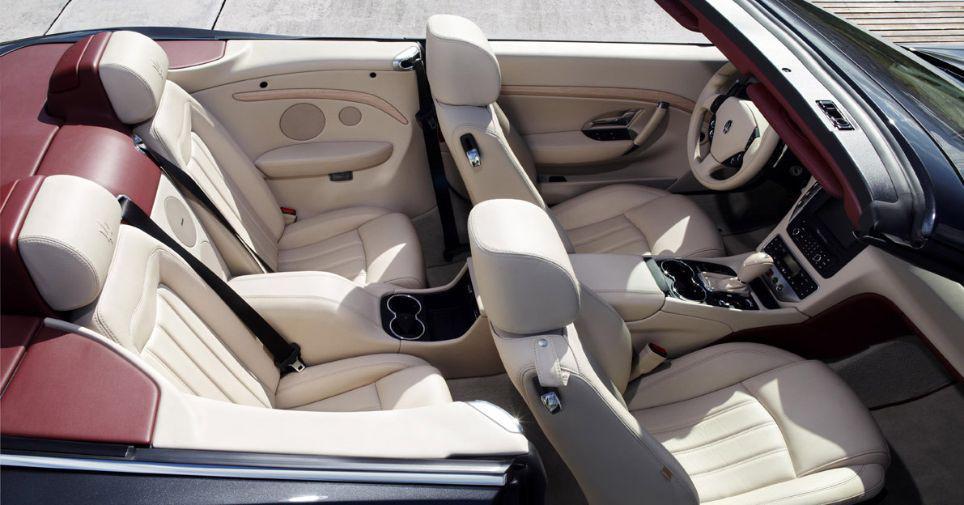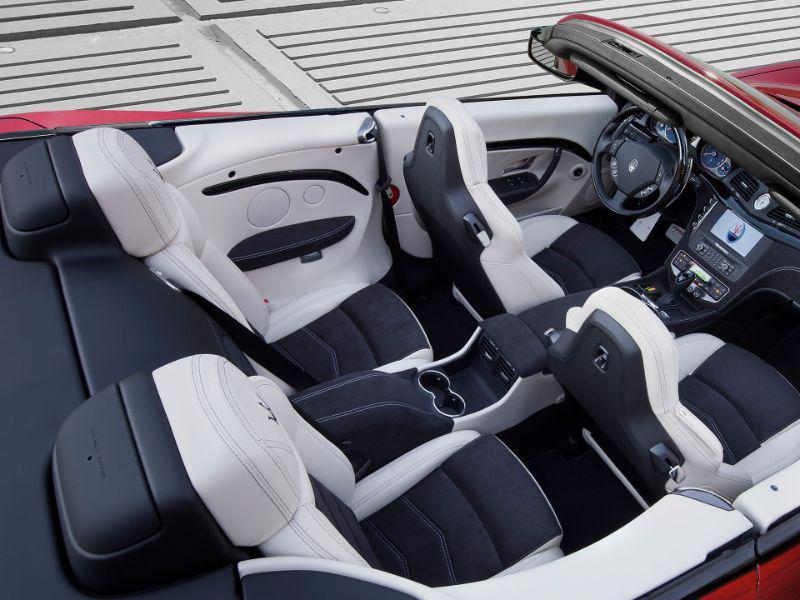The first image is the image on the left, the second image is the image on the right. Assess this claim about the two images: "Both car interiors show white upholstery, and no other color upholstery on the seats.". Correct or not? Answer yes or no. No. The first image is the image on the left, the second image is the image on the right. Examine the images to the left and right. Is the description "The steering wheel is visible on both cars, but the back seat is not." accurate? Answer yes or no. No. 